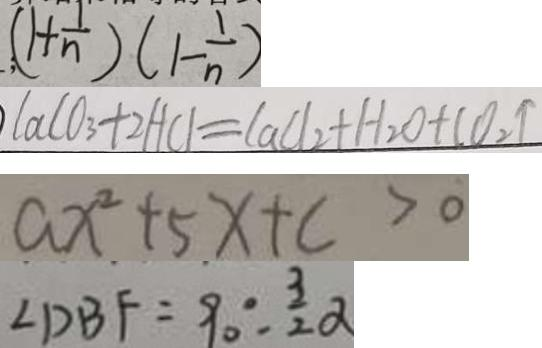<formula> <loc_0><loc_0><loc_500><loc_500>( 1 + \frac { 1 } { n } ) ( 1 - \frac { 1 } { n } ) 
 C a C O _ { 3 } + 2 H C l = C a C l _ { 2 } + H _ { 2 } O + C O _ { 2 } \uparrow 
 a x ^ { 2 } + 5 x + c > 0 
 \angle D B F = 9 0 ^ { \circ } - \frac { 3 } { 2 } \alpha</formula> 